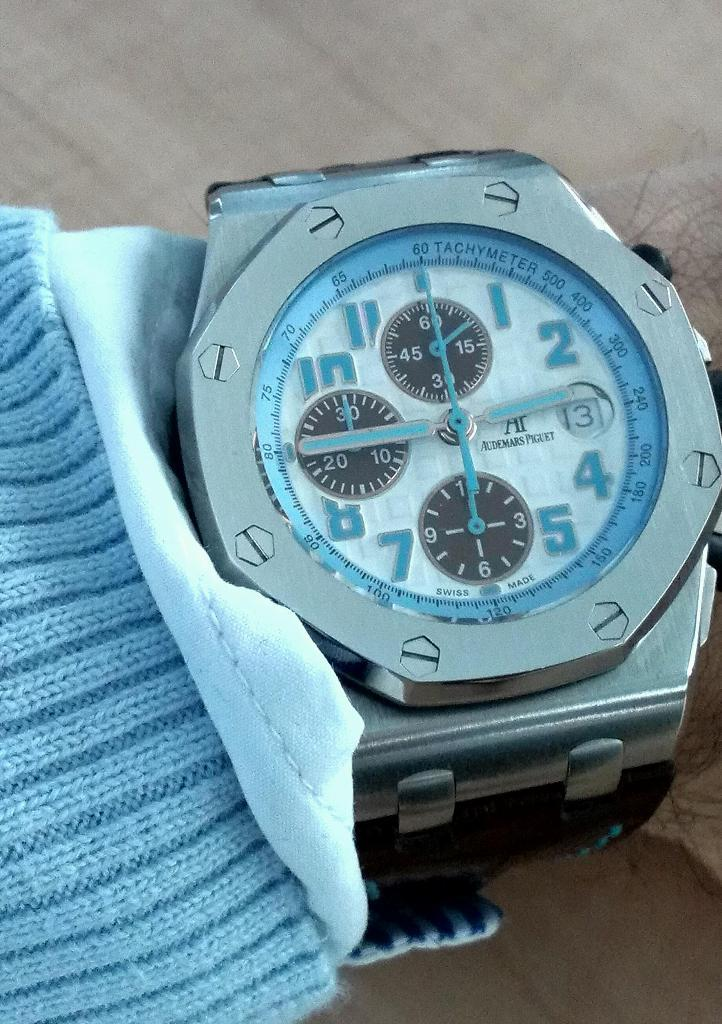<image>
Offer a succinct explanation of the picture presented. An Audemars Piguet watch has blue hands and blue numbers. 